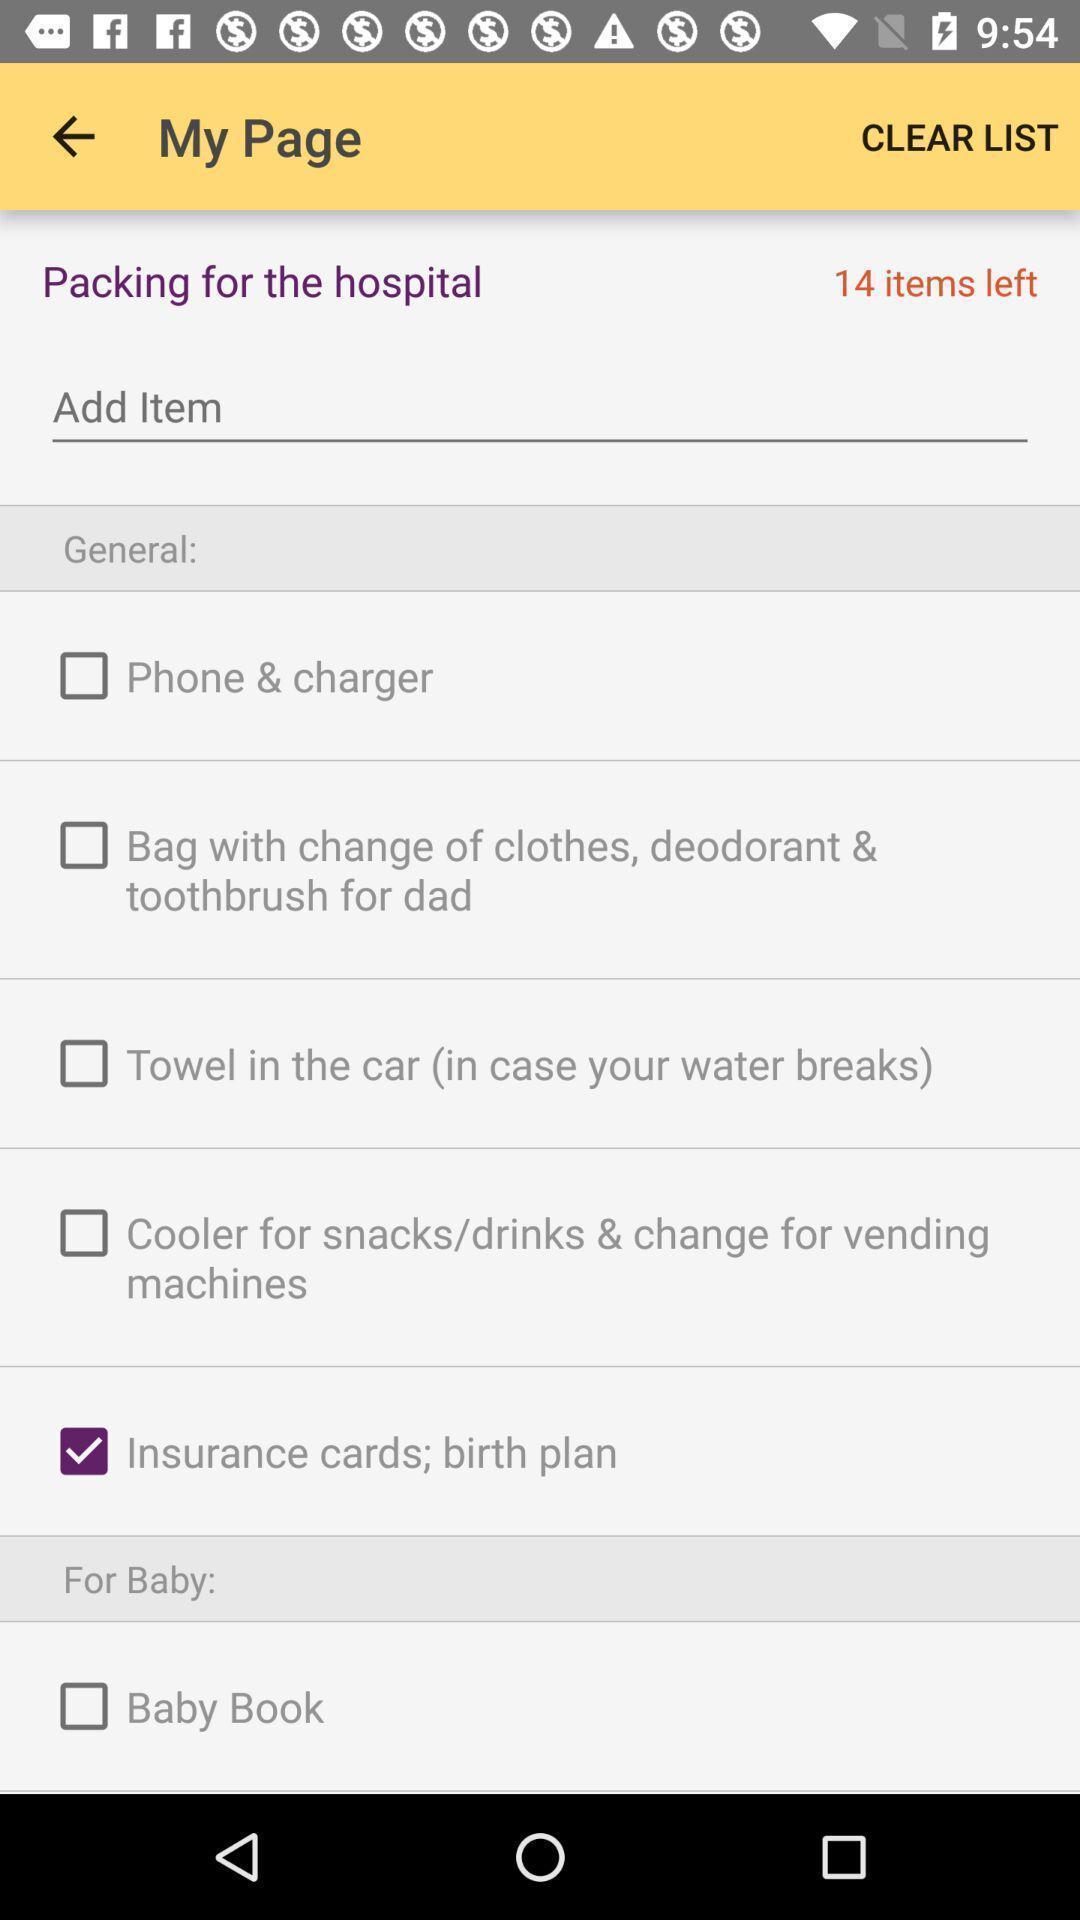Explain the elements present in this screenshot. Screen displaying my page in a health app. 